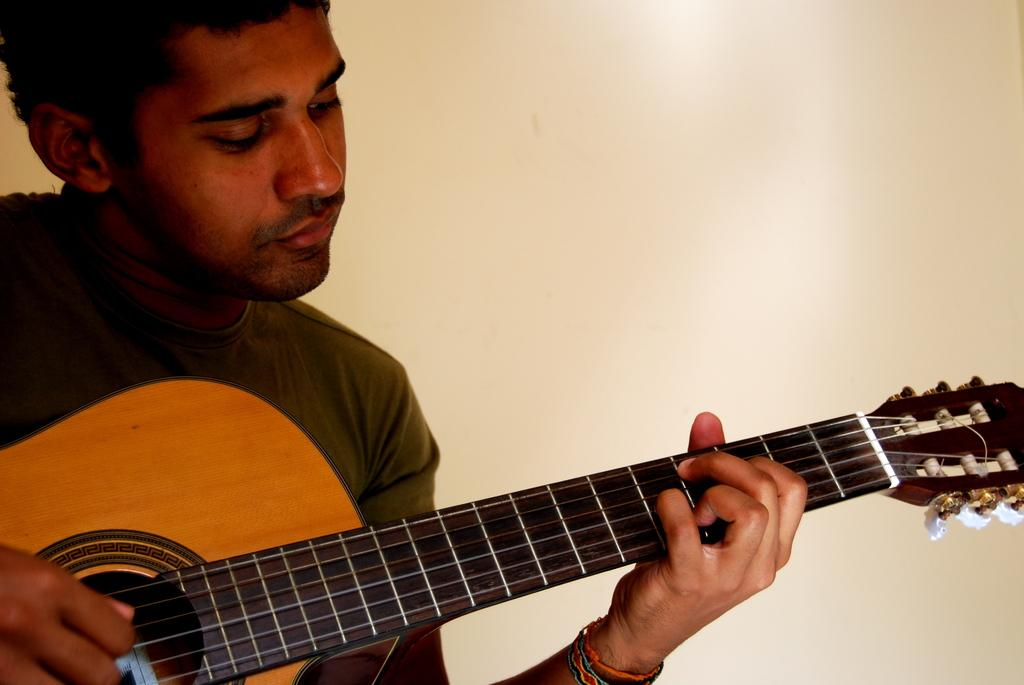What is the main subject of the image? The main subject of the image is a man. What is the man holding in the image? The man is holding a guitar. Where is the river flowing in the image? There is no river present in the image; it only features a man holding a guitar. 